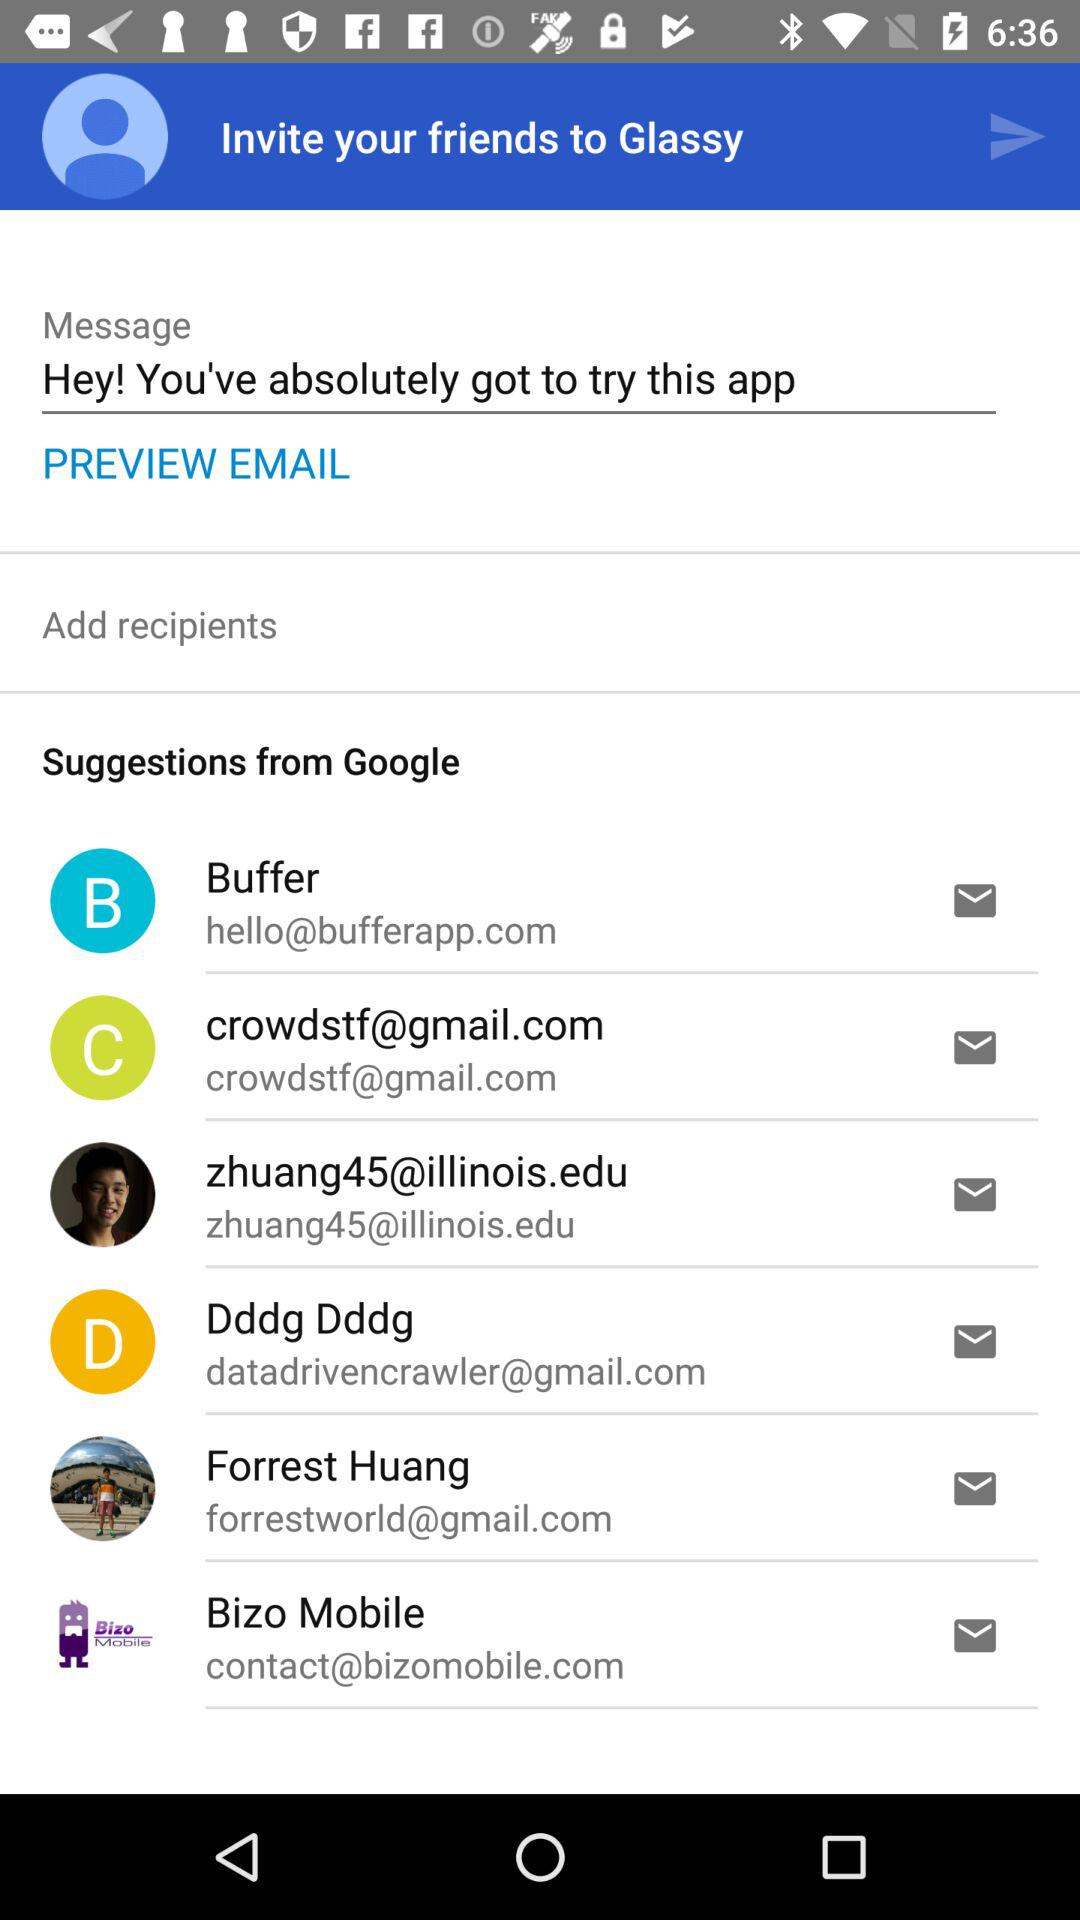What is the email address of Forrest Huang? The email address of Forrest Huang is forrestworld@gmail.com. 